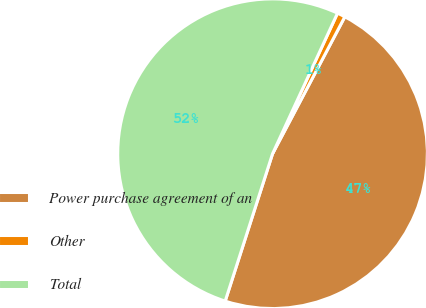Convert chart. <chart><loc_0><loc_0><loc_500><loc_500><pie_chart><fcel>Power purchase agreement of an<fcel>Other<fcel>Total<nl><fcel>47.22%<fcel>0.84%<fcel>51.94%<nl></chart> 